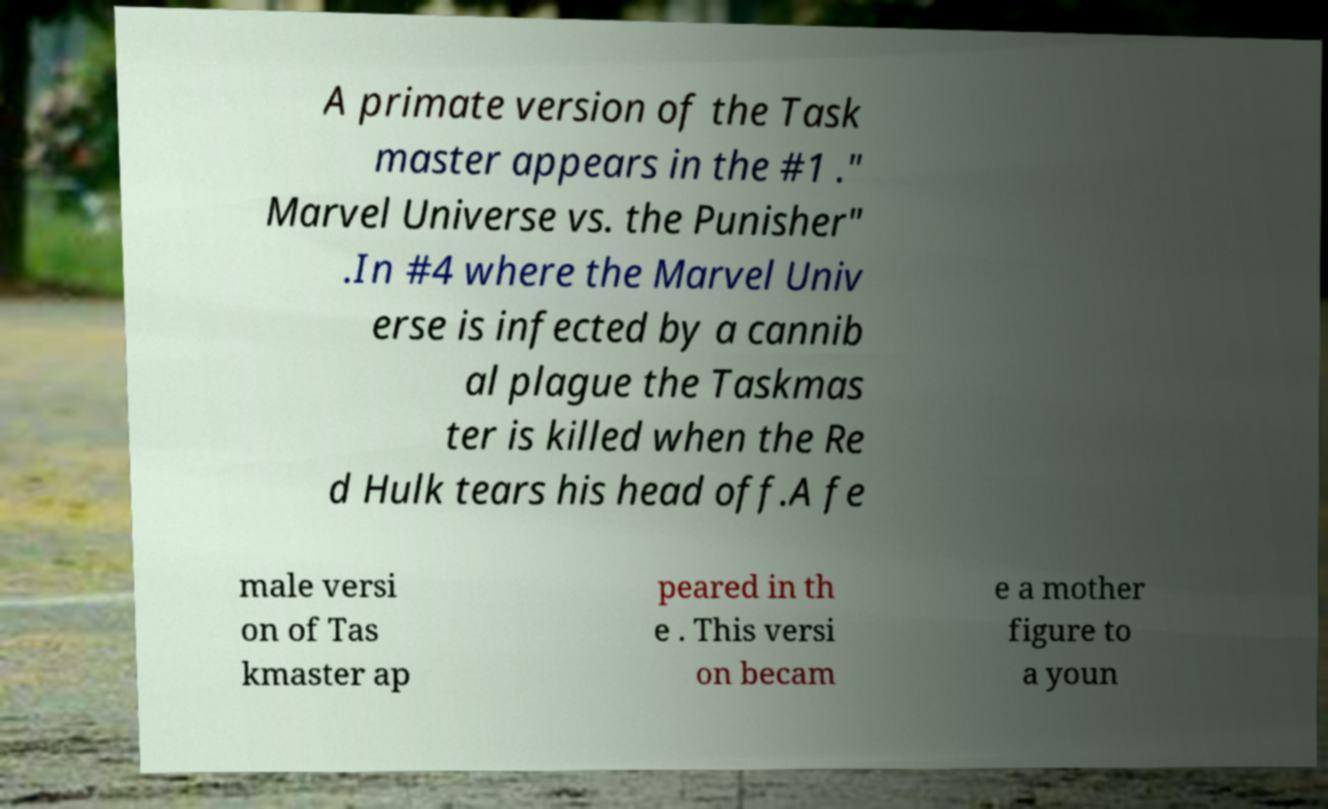Please read and relay the text visible in this image. What does it say? A primate version of the Task master appears in the #1 ." Marvel Universe vs. the Punisher" .In #4 where the Marvel Univ erse is infected by a cannib al plague the Taskmas ter is killed when the Re d Hulk tears his head off.A fe male versi on of Tas kmaster ap peared in th e . This versi on becam e a mother figure to a youn 